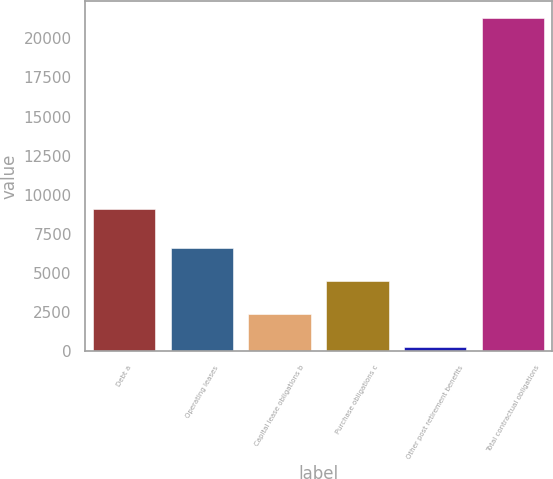Convert chart. <chart><loc_0><loc_0><loc_500><loc_500><bar_chart><fcel>Debt a<fcel>Operating leases<fcel>Capital lease obligations b<fcel>Purchase obligations c<fcel>Other post retirement benefits<fcel>Total contractual obligations<nl><fcel>9102<fcel>6615.1<fcel>2397.1<fcel>4516<fcel>298<fcel>21289<nl></chart> 